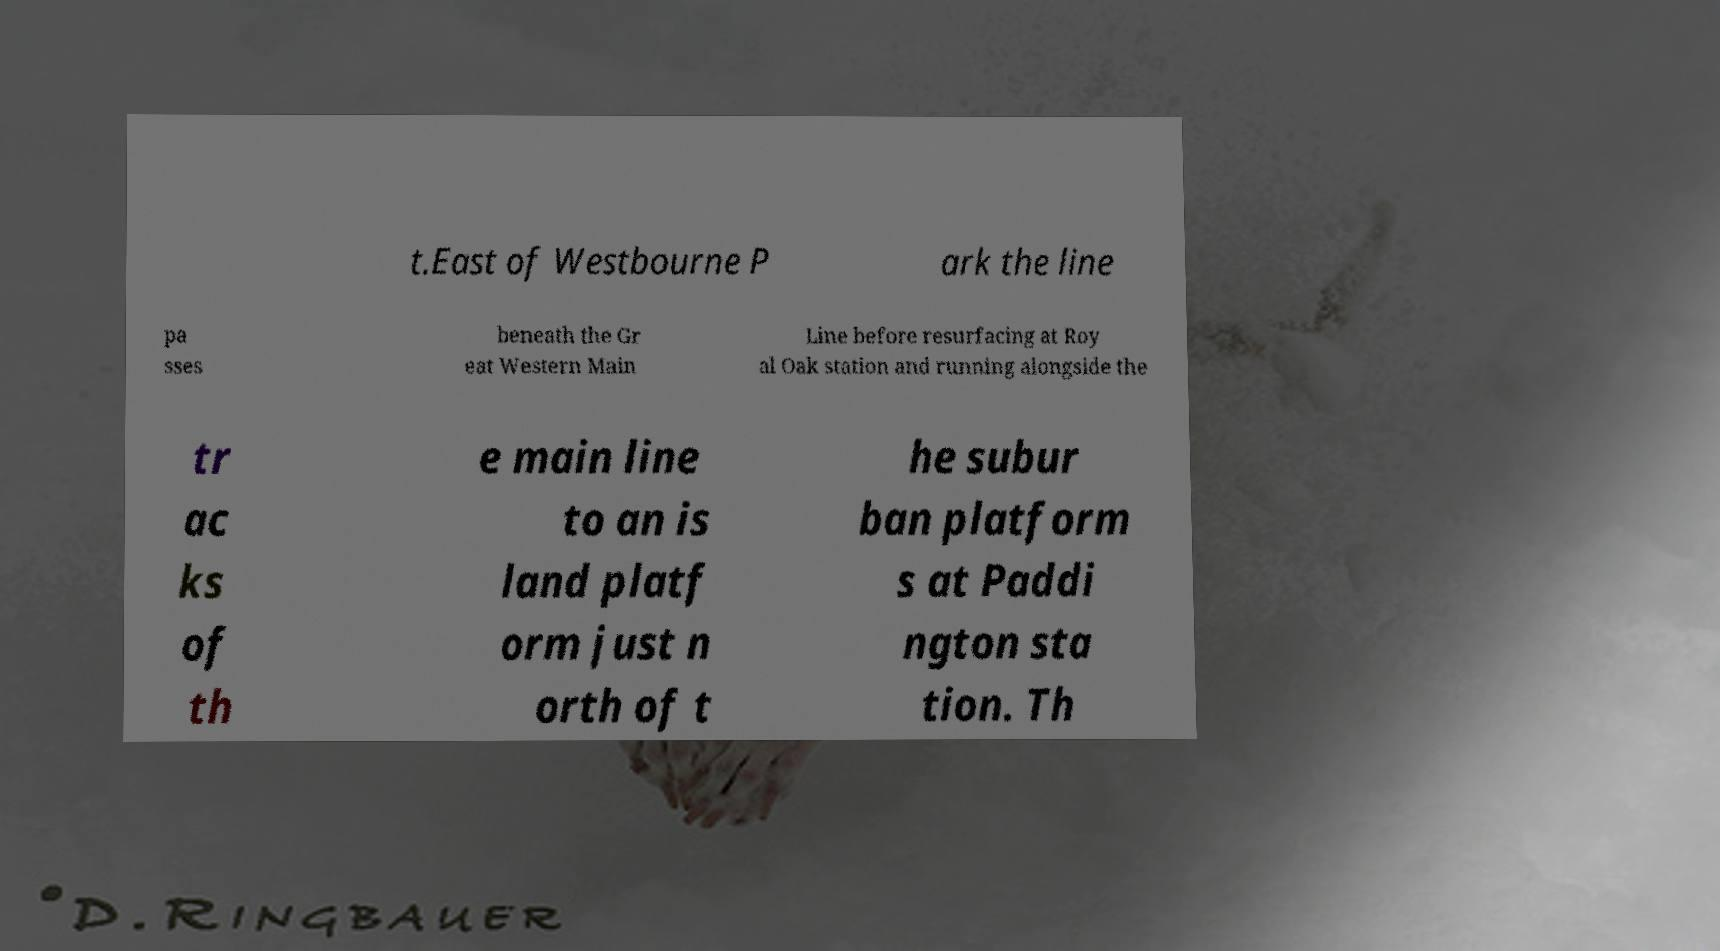For documentation purposes, I need the text within this image transcribed. Could you provide that? t.East of Westbourne P ark the line pa sses beneath the Gr eat Western Main Line before resurfacing at Roy al Oak station and running alongside the tr ac ks of th e main line to an is land platf orm just n orth of t he subur ban platform s at Paddi ngton sta tion. Th 